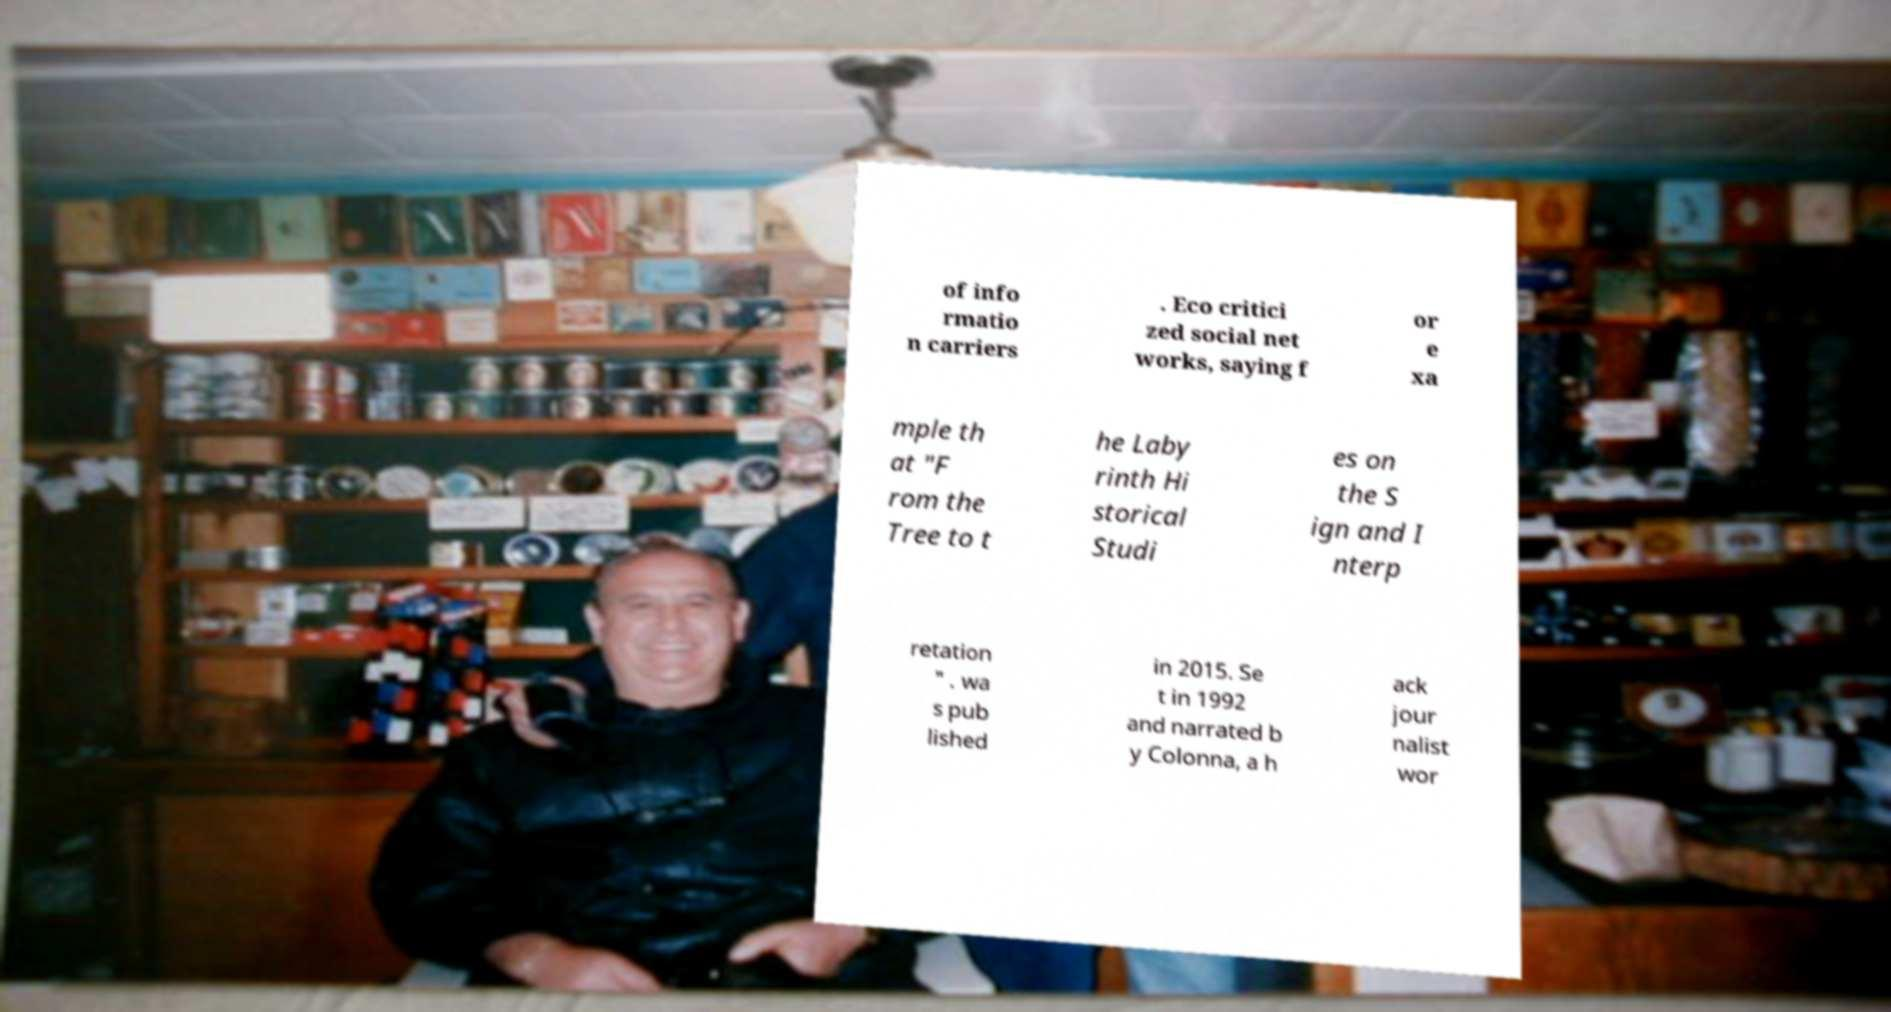Could you extract and type out the text from this image? of info rmatio n carriers . Eco critici zed social net works, saying f or e xa mple th at "F rom the Tree to t he Laby rinth Hi storical Studi es on the S ign and I nterp retation " . wa s pub lished in 2015. Se t in 1992 and narrated b y Colonna, a h ack jour nalist wor 